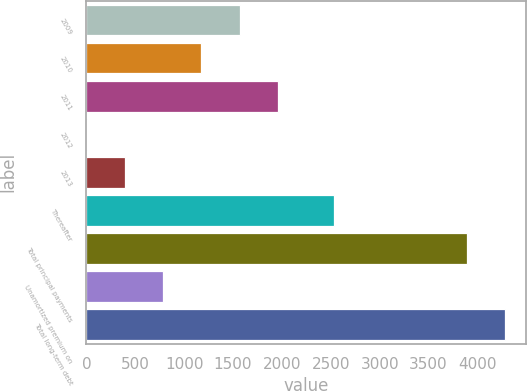Convert chart to OTSL. <chart><loc_0><loc_0><loc_500><loc_500><bar_chart><fcel>2009<fcel>2010<fcel>2011<fcel>2012<fcel>2013<fcel>Thereafter<fcel>Total principal payments<fcel>Unamortized premium on<fcel>Total long-term debt<nl><fcel>1569.2<fcel>1177.4<fcel>1961<fcel>2<fcel>393.8<fcel>2533<fcel>3888<fcel>785.6<fcel>4279.8<nl></chart> 